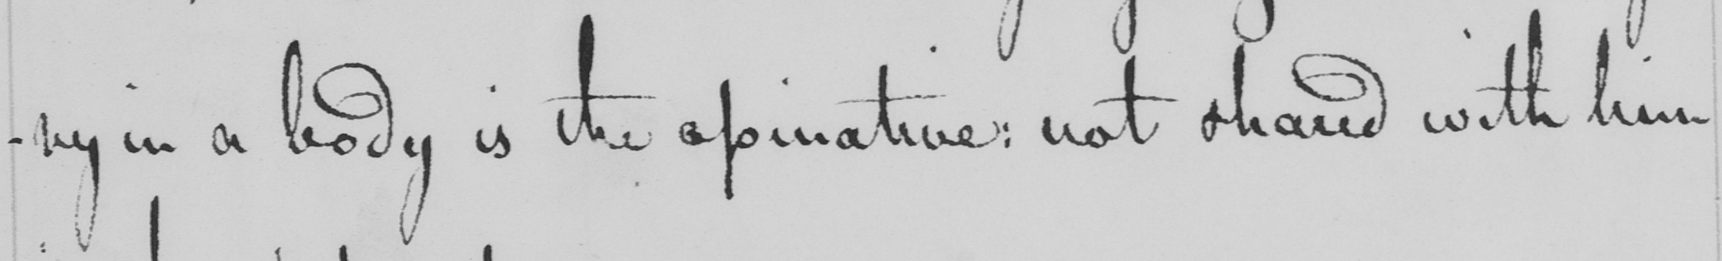Please transcribe the handwritten text in this image. ry in a body is the apinative :  not shared with him 